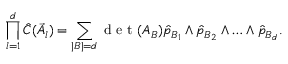<formula> <loc_0><loc_0><loc_500><loc_500>\prod _ { l = 1 } ^ { d } \hat { C } ( \vec { A } _ { l } ) = \sum _ { | B | = d } d e t ( A _ { B } ) \hat { p } _ { B _ { 1 } } \wedge \hat { p } _ { B _ { 2 } } \wedge \dots \wedge \hat { p } _ { B _ { d } } .</formula> 